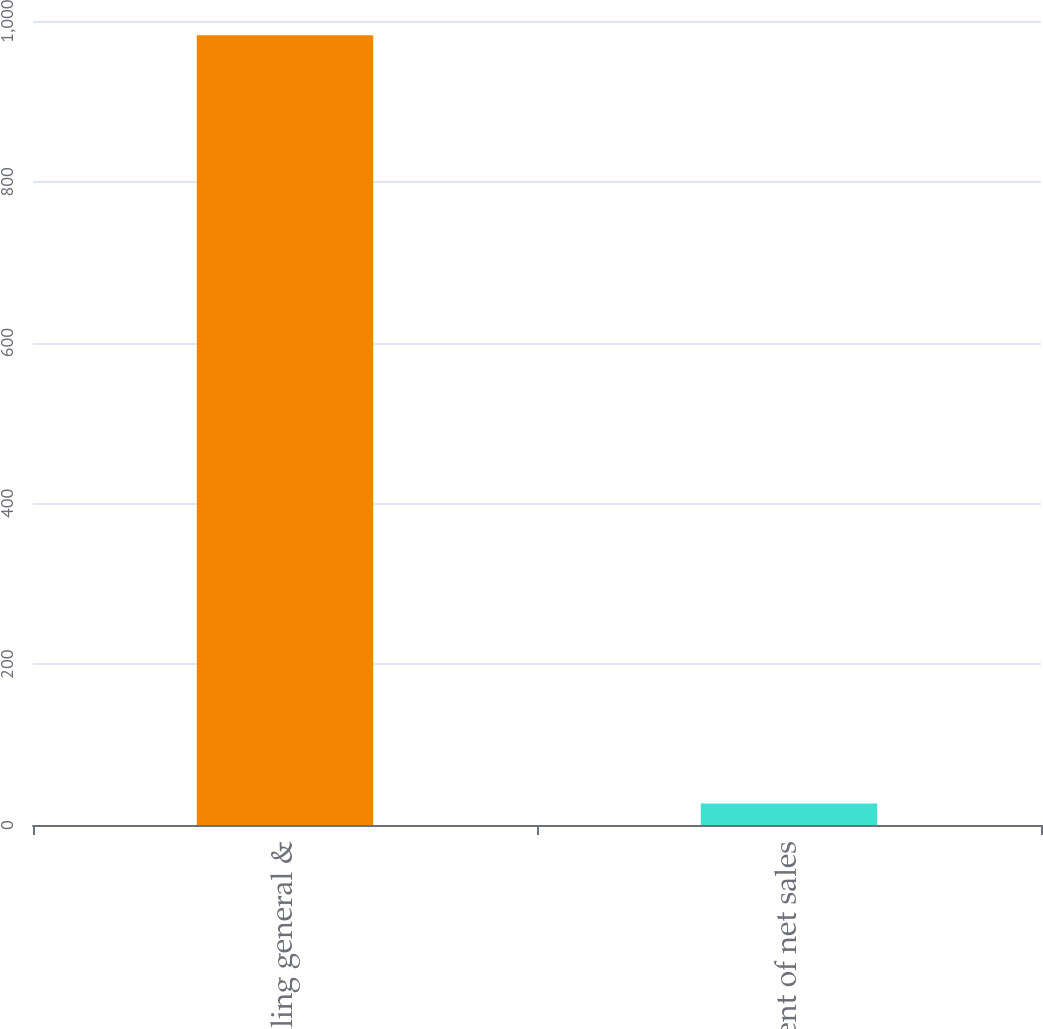Convert chart to OTSL. <chart><loc_0><loc_0><loc_500><loc_500><bar_chart><fcel>Selling general &<fcel>Percent of net sales<nl><fcel>982.2<fcel>26.6<nl></chart> 